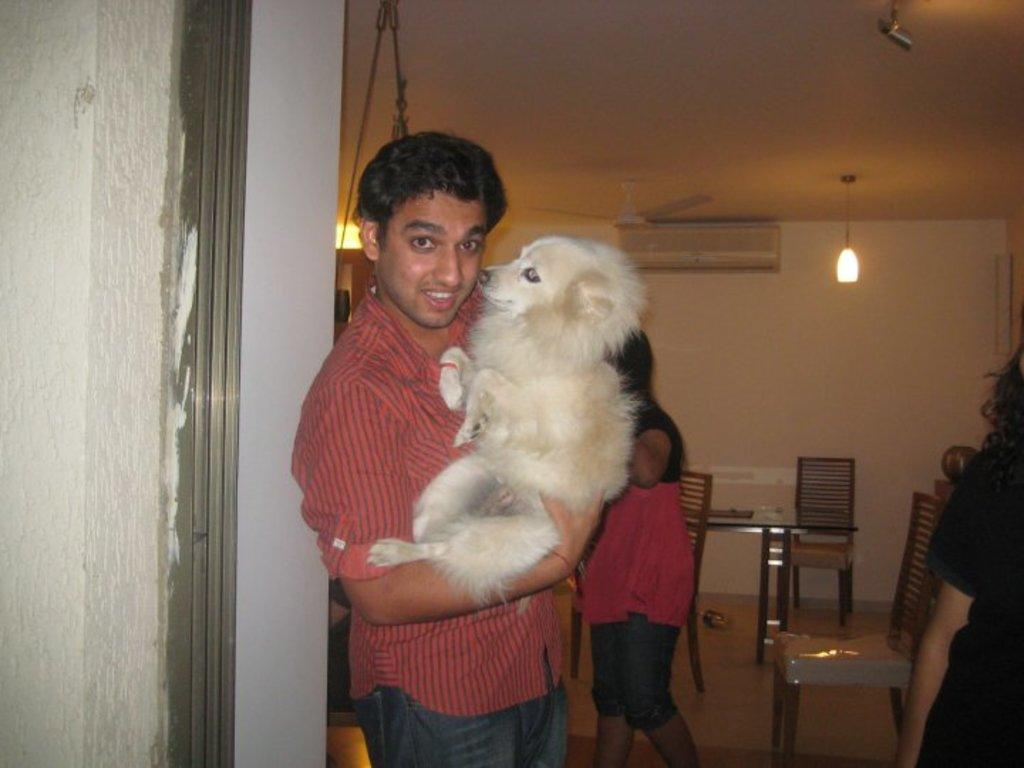Who is in the image? There is a person in the image. What is the person wearing? The person is wearing a red shirt. What is the person doing in the image? The person is catching a puppy. What can be seen in the background of the image? There is a fan, a light, and a chair in the background of the image. How does the carriage in the image help the person catch the puppy? There is no carriage present in the image; the person is simply catching a puppy. 